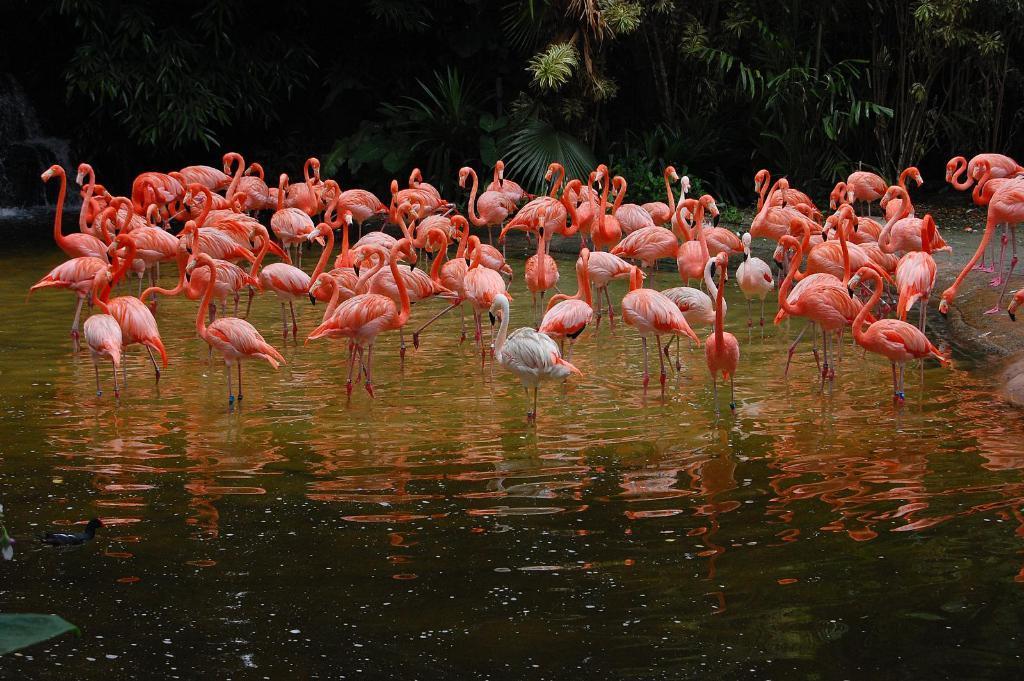Can you describe this image briefly? In this image, we can see a group of swans are in the water. Top of the image, we can see so many trees and plants. Left side of the image, we can see a waterfall. 